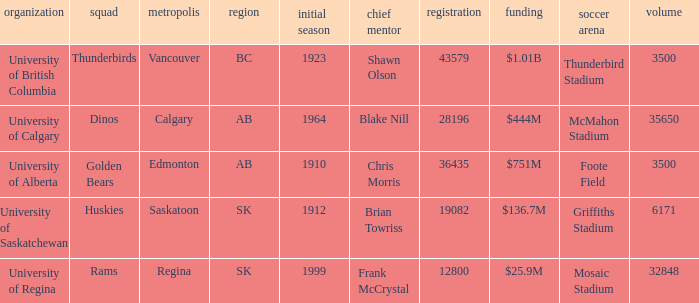What is the enrollment for Foote Field? 36435.0. 